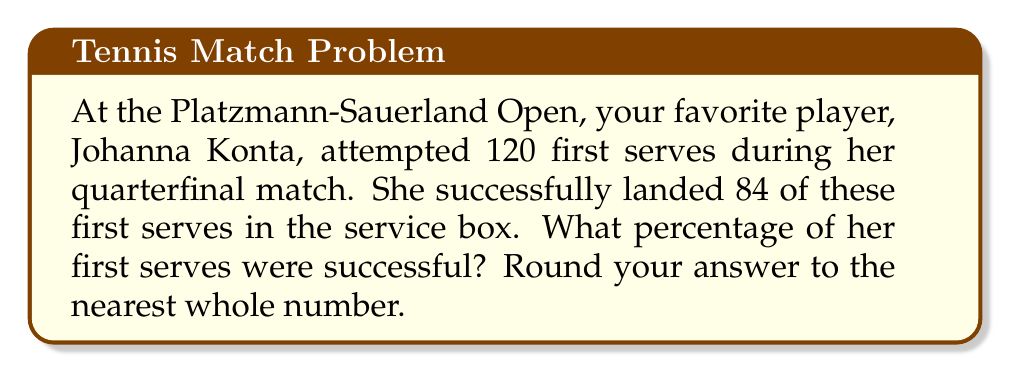Could you help me with this problem? To calculate the percentage of successful first serves, we need to use the following formula:

$$ \text{Percentage} = \frac{\text{Number of successful serves}}{\text{Total number of serve attempts}} \times 100\% $$

Let's plug in the values we know:
* Number of successful serves = 84
* Total number of serve attempts = 120

$$ \text{Percentage} = \frac{84}{120} \times 100\% $$

Now, let's solve this step by step:

1) First, divide 84 by 120:
   $\frac{84}{120} = 0.7$

2) Multiply this result by 100 to get the percentage:
   $0.7 \times 100 = 70\%$

3) The question asks to round to the nearest whole number, but 70 is already a whole number, so no further rounding is necessary.

Therefore, Johanna Konta's percentage of successful first serves was 70%.
Answer: 70% 